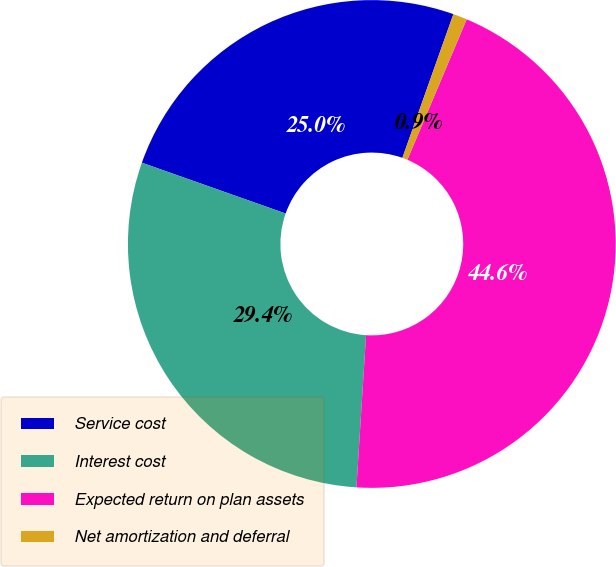Convert chart to OTSL. <chart><loc_0><loc_0><loc_500><loc_500><pie_chart><fcel>Service cost<fcel>Interest cost<fcel>Expected return on plan assets<fcel>Net amortization and deferral<nl><fcel>25.02%<fcel>29.4%<fcel>44.64%<fcel>0.93%<nl></chart> 